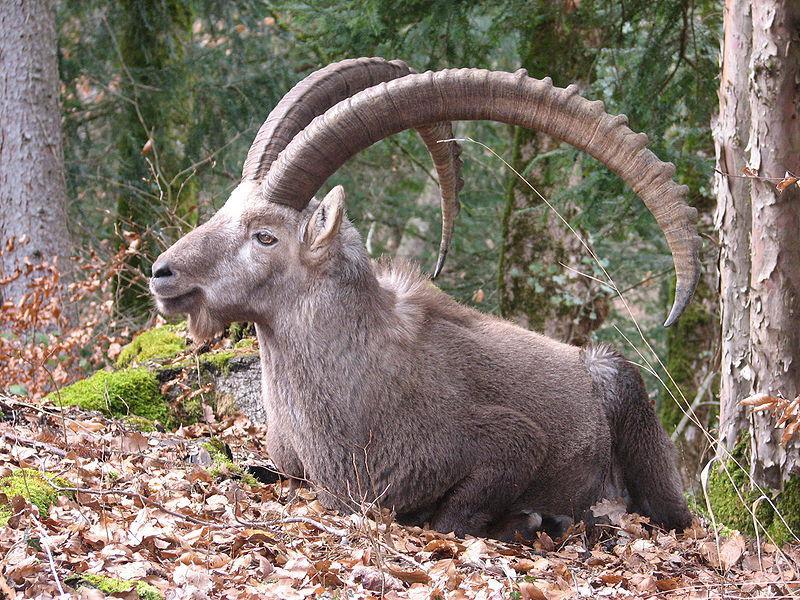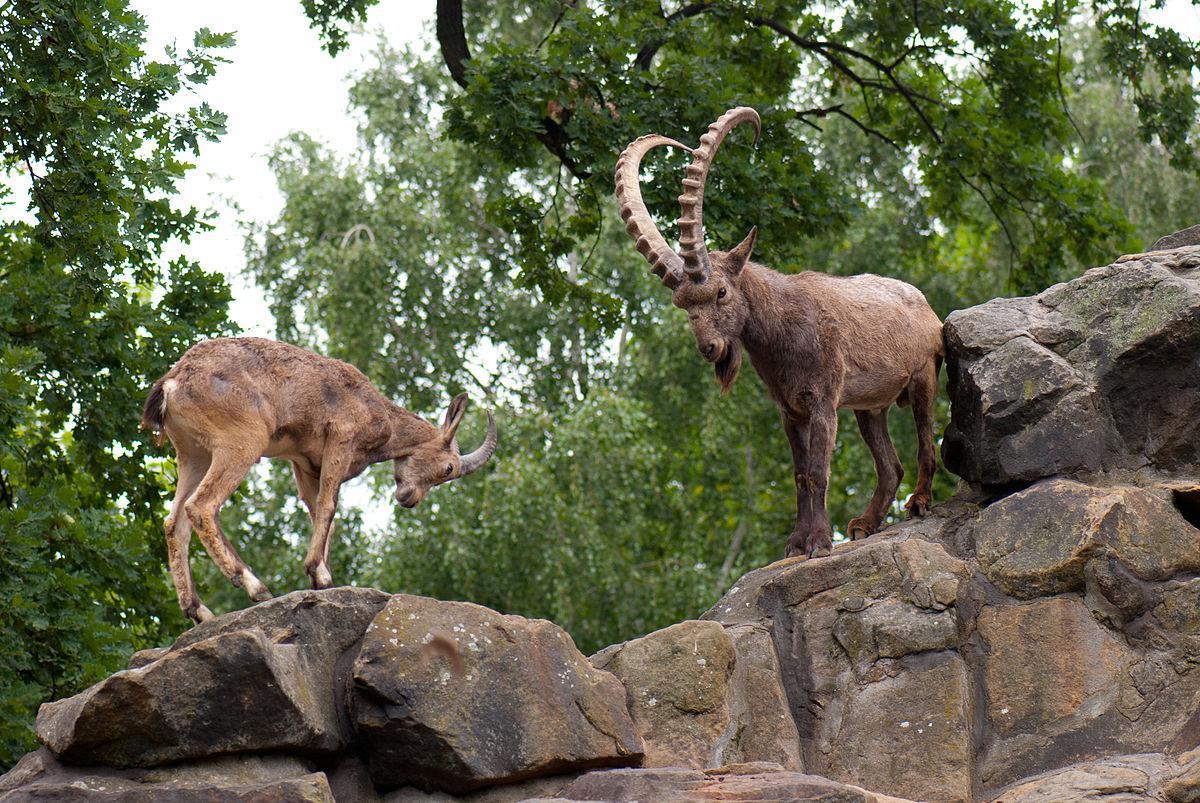The first image is the image on the left, the second image is the image on the right. Assess this claim about the two images: "The right image contains two animals standing on a rock.". Correct or not? Answer yes or no. Yes. The first image is the image on the left, the second image is the image on the right. Analyze the images presented: Is the assertion "An image shows two horned animals facing toward each other on a stony slope." valid? Answer yes or no. Yes. 